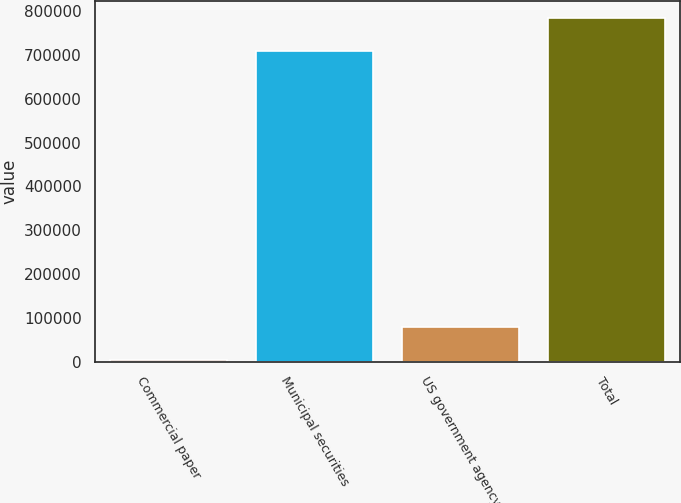Convert chart. <chart><loc_0><loc_0><loc_500><loc_500><bar_chart><fcel>Commercial paper<fcel>Municipal securities<fcel>US government agency<fcel>Total<nl><fcel>3978<fcel>709078<fcel>79552.7<fcel>784653<nl></chart> 